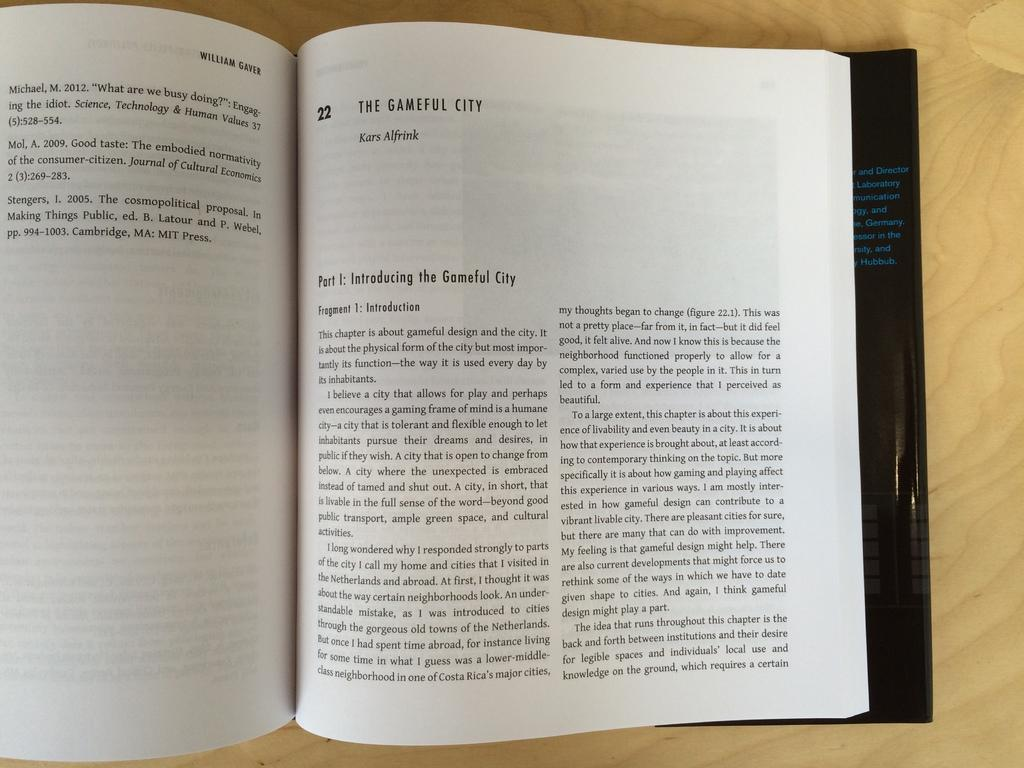<image>
Provide a brief description of the given image. A book is open to part one of chapter twenty two. 